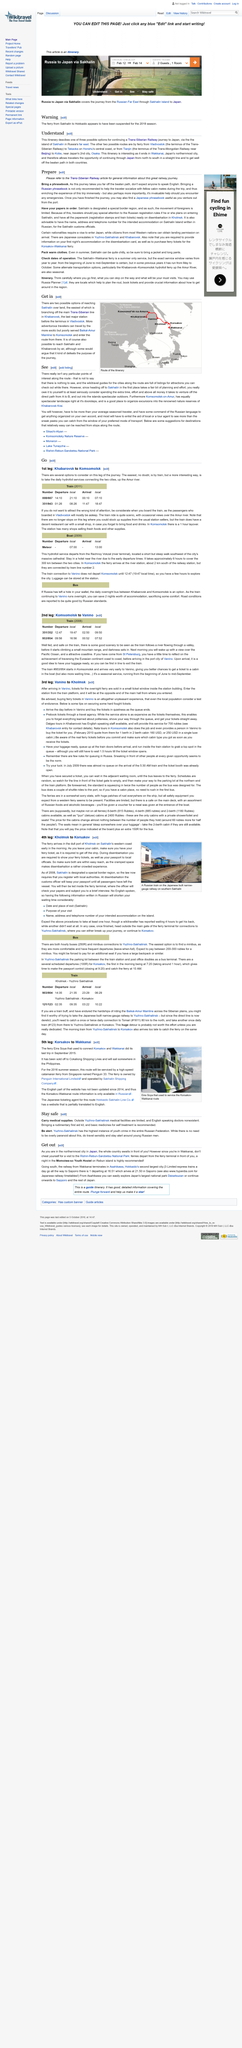Highlight a few significant elements in this photo. The last major station on the Trans-Siberian Line before reaching the terminus in Vladivostok is Khabarovsk. Yes, it is possible to reach Sakhalin and Khabarovsk by air from Wakkanai. The Trans-Mongolian line passes through a major Chinese city en route to Moscow, and that city is Beijing. 